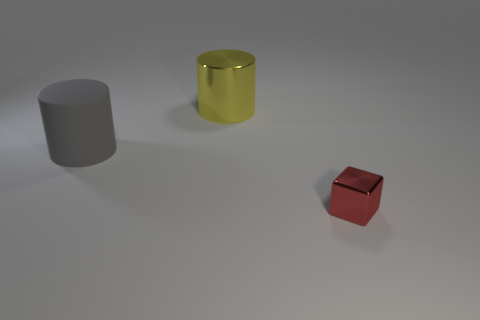Add 2 large metal cylinders. How many objects exist? 5 Subtract all gray cylinders. How many cylinders are left? 1 Subtract all cubes. Subtract all tiny red metal blocks. How many objects are left? 1 Add 1 tiny shiny objects. How many tiny shiny objects are left? 2 Add 3 small metal things. How many small metal things exist? 4 Subtract 0 cyan cylinders. How many objects are left? 3 Subtract all cubes. How many objects are left? 2 Subtract 1 cylinders. How many cylinders are left? 1 Subtract all gray cylinders. Subtract all cyan spheres. How many cylinders are left? 1 